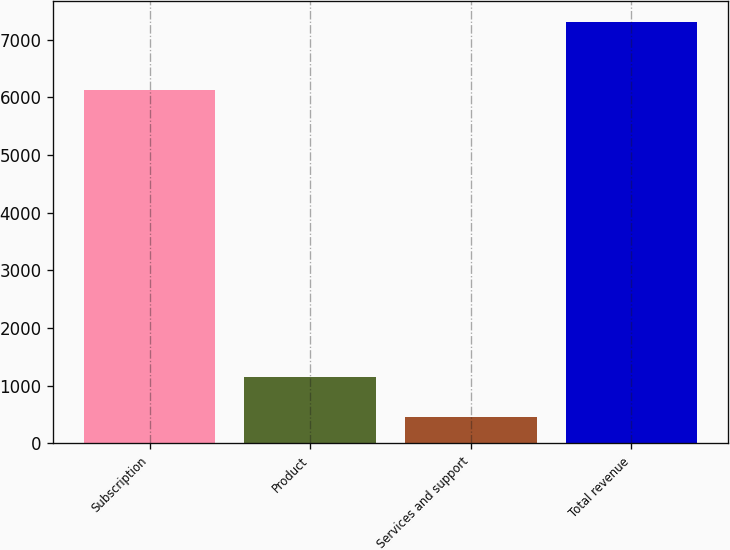Convert chart to OTSL. <chart><loc_0><loc_0><loc_500><loc_500><bar_chart><fcel>Subscription<fcel>Product<fcel>Services and support<fcel>Total revenue<nl><fcel>6133.9<fcel>1144.96<fcel>460.9<fcel>7301.5<nl></chart> 